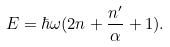<formula> <loc_0><loc_0><loc_500><loc_500>E = \hbar { \omega } ( 2 n + \frac { n ^ { \prime } } { \alpha } + 1 ) .</formula> 